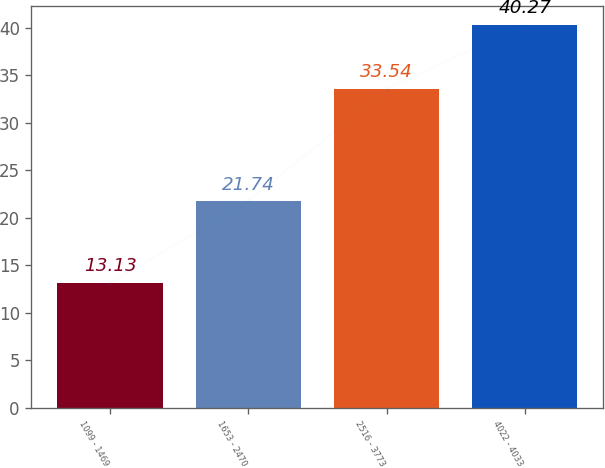<chart> <loc_0><loc_0><loc_500><loc_500><bar_chart><fcel>1099 - 1469<fcel>1653 - 2470<fcel>2516 - 3773<fcel>4022 - 4033<nl><fcel>13.13<fcel>21.74<fcel>33.54<fcel>40.27<nl></chart> 